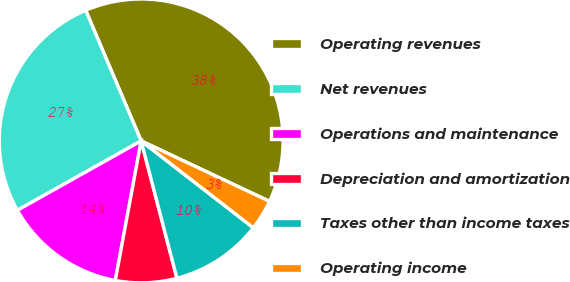Convert chart. <chart><loc_0><loc_0><loc_500><loc_500><pie_chart><fcel>Operating revenues<fcel>Net revenues<fcel>Operations and maintenance<fcel>Depreciation and amortization<fcel>Taxes other than income taxes<fcel>Operating income<nl><fcel>38.4%<fcel>26.74%<fcel>13.95%<fcel>6.97%<fcel>10.46%<fcel>3.48%<nl></chart> 